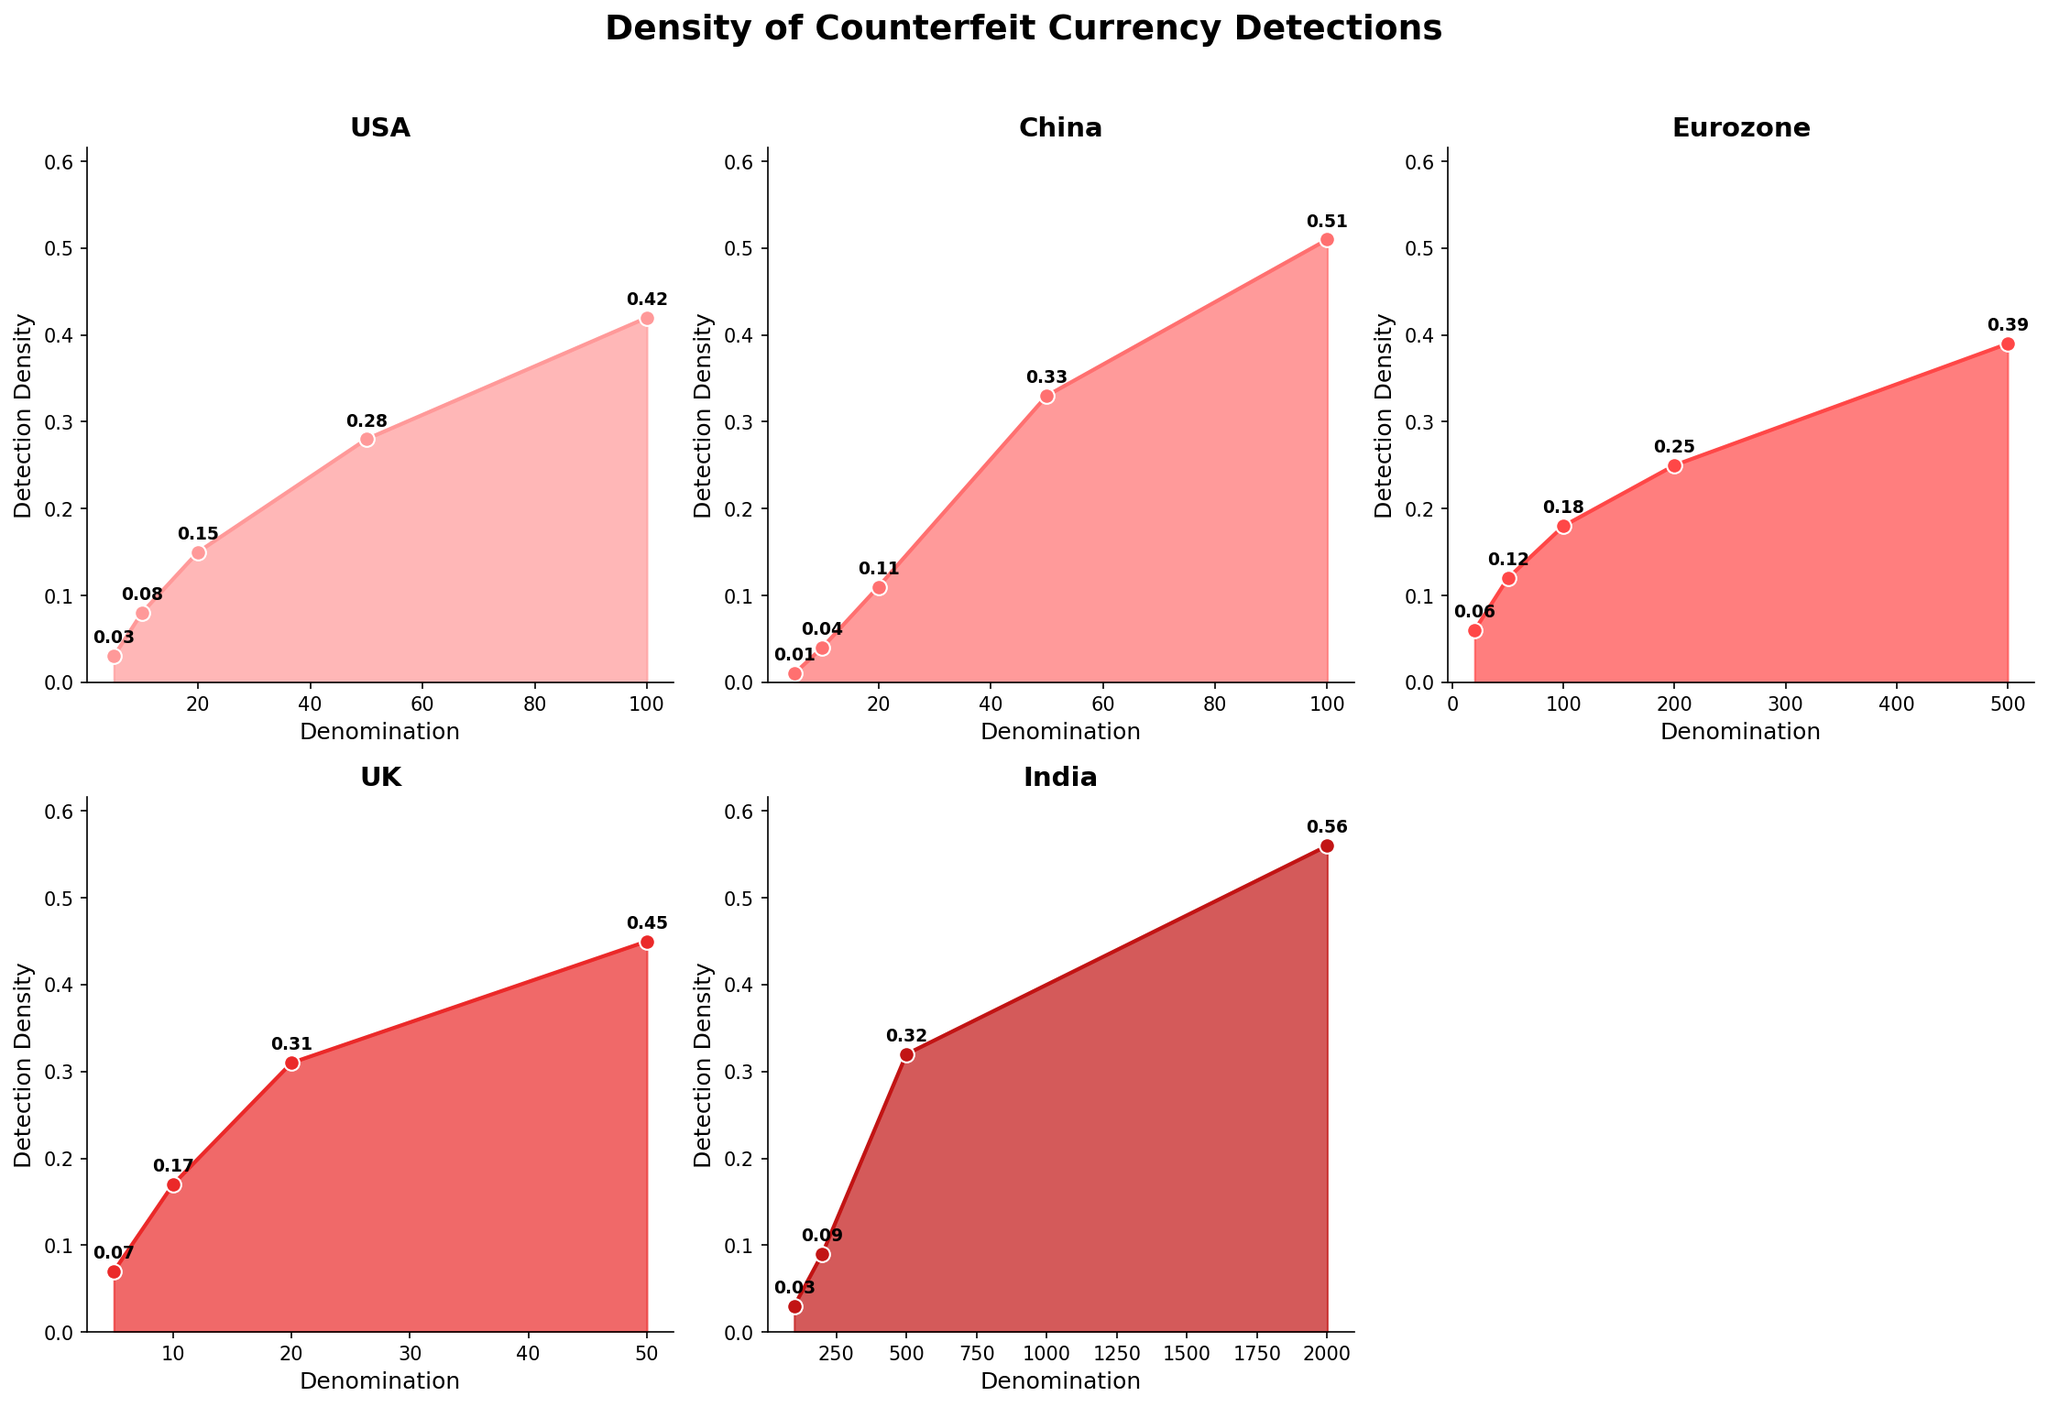What is the detection density of counterfeit $50 bills in the USA? Look at the subplot labeled "USA" and find the point corresponding to the $50 denomination. The detection density for this point is marked next to the line.
Answer: 0.28 What country has the highest detection density for any denomination, and which denomination is it? Compare the detection densities across all subplots. The highest detection density value is 0.56 which appears in the subplot labeled "India", for the 2000 denomination.
Answer: India, 2000 denomination By how much does the detection density of €500 bills exceed that of €50 bills in the Eurozone? Find the detection density of €500 bills and €50 bills in the subplot labeled "Eurozone". They are marked as 0.39 for the €500 bills and 0.12 for the €50 bills. Calculate the difference: 0.39 - 0.12.
Answer: 0.27 Which country has the least variation in detection densities across all denominations? Compare the range (max - min) of the detection densities in each subplot. The subplot labeled "USA" has the detection densities ranging from 0.42 to 0.03 which gives a range of 0.39. Check ranges for other countries to confirm. The UK has the range from 0.45 to 0.07 which is 0.38. India has the range from 0.56 to 0.03 which is 0.53. Eurozone has a range from 0.39 to 0.06 which is 0.33. China has a range of 0.51 to 0.01 which is 0.50. The country with the least variation is Eurozone with a range of 0.33.
Answer: Eurozone In the subplot for the UK, what is the detection density for the lowest denomination provided? Find the lowest denomination in the UK subplot which is 5. The detection density for the £5 bills is marked on the plot and is 0.07.
Answer: 0.07 Is there a country where the detection density increases uniformly as the denomination increases? Check each subplot to see if the detection density increases consistently with increasing denomination values. None of the subplots show a uniform increase. However, the plot for China shows an approximate decreasing trend.
Answer: No Is the detection density of ¥100 bills in China higher than that of $100 bills in the USA? Compare the detection densities of ¥100 in China and $100 in the USA. They are marked as 0.51 for ¥100 and 0.42 for $100.
Answer: Yes How does the detection density of ₹500 compare to ¥50? Find the detection density of ₹500 in India's subplot (0.32) and ¥50 in China's subplot (0.33). Compare the two values.
Answer: lower by 0.01 